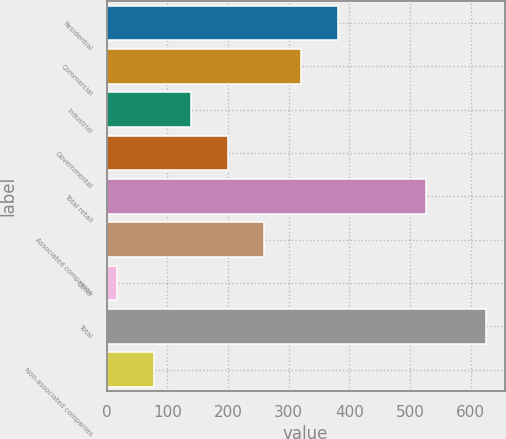<chart> <loc_0><loc_0><loc_500><loc_500><bar_chart><fcel>Residential<fcel>Commercial<fcel>Industrial<fcel>Governmental<fcel>Total retail<fcel>Associated companies<fcel>Other<fcel>Total<fcel>Non-associated companies<nl><fcel>381.8<fcel>321<fcel>138.6<fcel>199.4<fcel>526<fcel>260.2<fcel>17<fcel>625<fcel>77.8<nl></chart> 